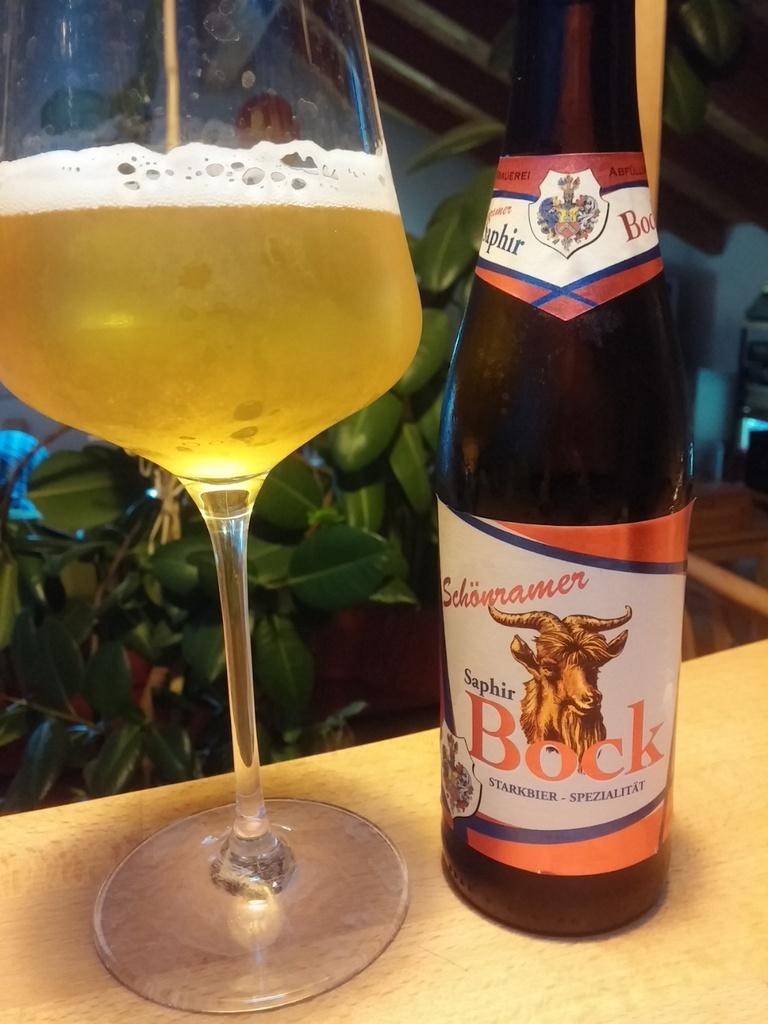What brand of beer is this?
Keep it short and to the point. Bock. 